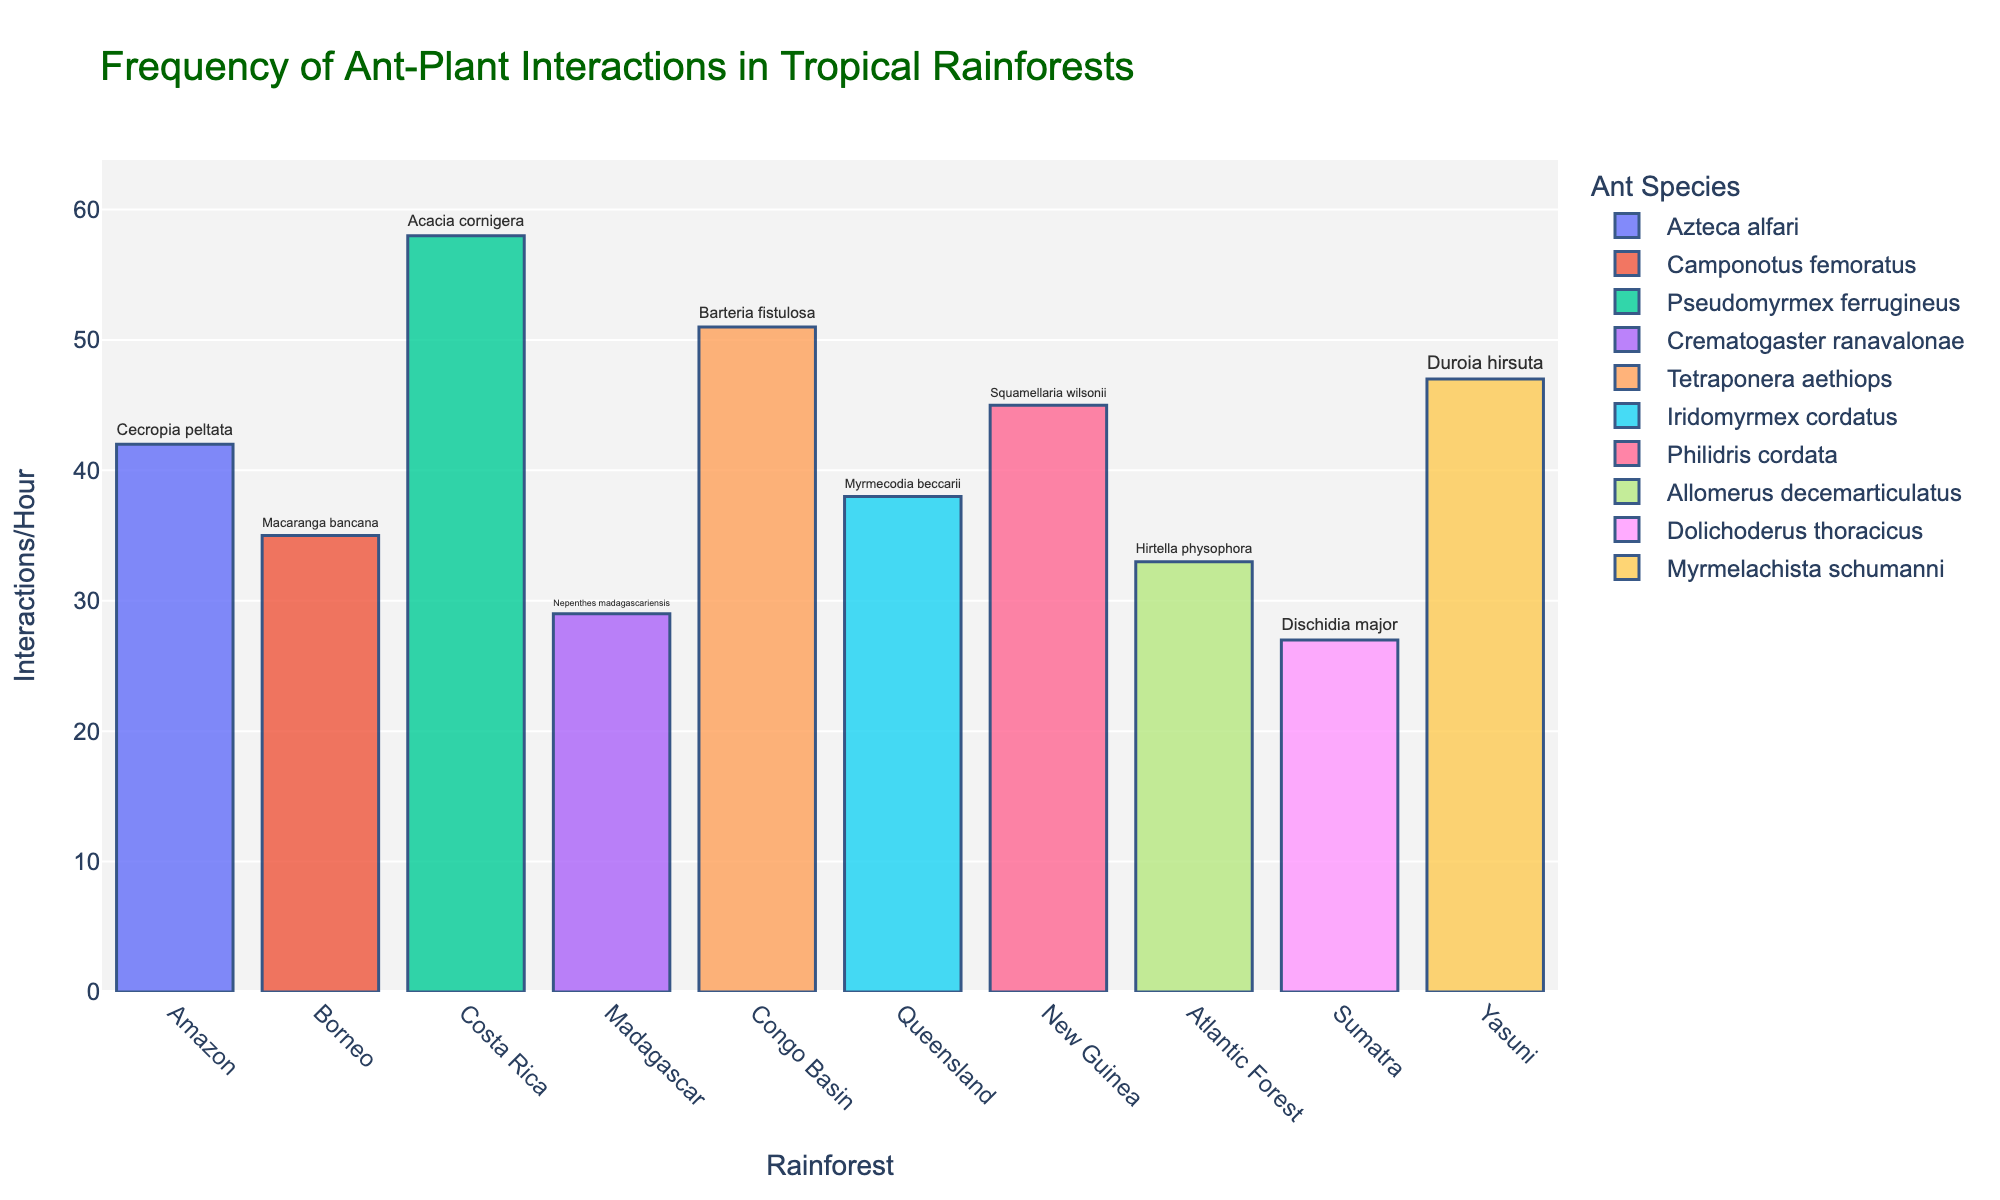Which rainforest has the highest frequency of ant-plant interactions per hour? Look at the heights of the bars and find the tallest one. The tallest bar represents the frequency for Costa Rica, indicating it has the highest interactions per hour.
Answer: Costa Rica Which rainforest has the lowest frequency of ant-plant interactions per hour? Look at the heights of the bars and identify the shortest one. The shortest bar represents Sumatra.
Answer: Sumatra Compare the interactions per hour between the Amazon and Madagascar rainforests. Which one has more? Check the heights of the bars for both the Amazon and Madagascar. The Amazon bar is taller than the Madagascar bar.
Answer: Amazon What is the sum of interactions per hour observed in New Guinea and Borneo rainforests? Find the bars for New Guinea and Borneo and add their values: 45 (New Guinea) + 35 (Borneo) = 80.
Answer: 80 Which rainforest has more interactions per hour, Queensland or Yasuni? Look at the heights of the bars for Queensland and Yasuni. The Yasuni bar is taller than the Queensland bar.
Answer: Yasuni What is the average number of interactions per hour across all rainforests? Sum all the interactions per hour values and divide by the number of rainforests: (42 + 35 + 58 + 29 + 51 + 38 + 45 + 33 + 27 + 47) / 10 = 405 / 10.
Answer: 40.5 What are the plant species involved in interactions in the Congo Basin rainforest? Read the text labels on the bar corresponding to the Congo Basin rainforest and find the plant species.
Answer: Barteria fistulosa Which ant species is observed in the Amazon rainforest? Look at the color associated with the Amazon's bar and match it to its legend entry. The ant species is Azteca alfari.
Answer: Azteca alfari Compare the interactions per hour between New Guinea and Atlantic Forest. Which one has fewer interactions per hour? Check the heights of the bars for New Guinea and Atlantic Forest. The Atlantic Forest bar is shorter.
Answer: Atlantic Forest 